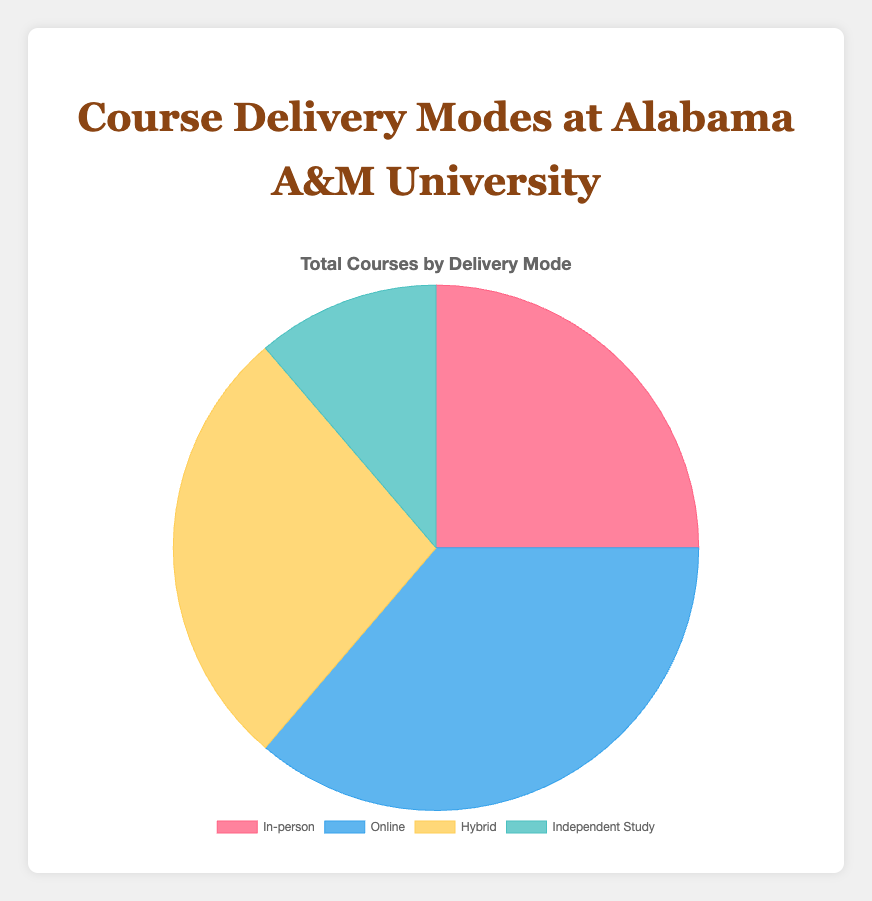In which mode is the largest number of courses offered? The pie chart shows four segments representing different course delivery modes. The segment labeled "Online" is visually the largest among the four, indicating that the largest number of courses is offered online.
Answer: Online Which mode has the least number of courses? By examining the size of the segments in the pie chart, it is clear that the "Independent Study" segment is the smallest. Thus, the least number of courses is offered as independent study.
Answer: Independent Study What is the combined total of courses offered in the Online and Hybrid modes? From the pie chart, the segment for Online courses has 145 courses, and the segment for Hybrid courses has 110 courses. Adding these together gives 145 + 110 = 255.
Answer: 255 How does the number of In-person courses compare to the number of Hybrid courses? The pie chart indicates that there are 100 In-person courses and 110 Hybrid courses. Thus, there are 10 more Hybrid courses than In-person courses.
Answer: 10 more Hybrid What fraction of the courses are offered In-person versus the total number of courses? The total number of courses is the sum of all the segments: 100 (In-person) + 145 (Online) + 110 (Hybrid) + 45 (Independent Study) = 400. The fraction for In-person courses is 100/400. Simplifying this fraction, we get 1/4 or 25%.
Answer: 25% By how much does the number of Online courses exceed the number of Independent Study courses? The number of Online courses is 145, and the number of Independent Study courses is 45. The difference is 145 - 45 = 100.
Answer: 100 What is the color representing Hybrid courses in the pie chart? In the pie chart, each delivery mode is colored differently. The Hybrid segment is represented by the yellow color.
Answer: Yellow Which two modes have the closest number of courses offered? From the data and visual inspection, In-person courses are 100, and Hybrid courses are 110. The difference is 10, which is the smallest difference among the other pairs. Thus, In-person and Hybrid courses have the closest numbers.
Answer: In-person and Hybrid If the university decided to increase the number of Online courses by 55, how many total Online courses would there be? The current number of Online courses is 145. Adding 55 to this number, 145 + 55 = 200.
Answer: 200 What percentage of courses are delivered through Independent Study? The number of Independent Study courses is 45 out of a total of 400 courses. To find the percentage, (45/400) * 100 = 11.25%.
Answer: 11.25% 